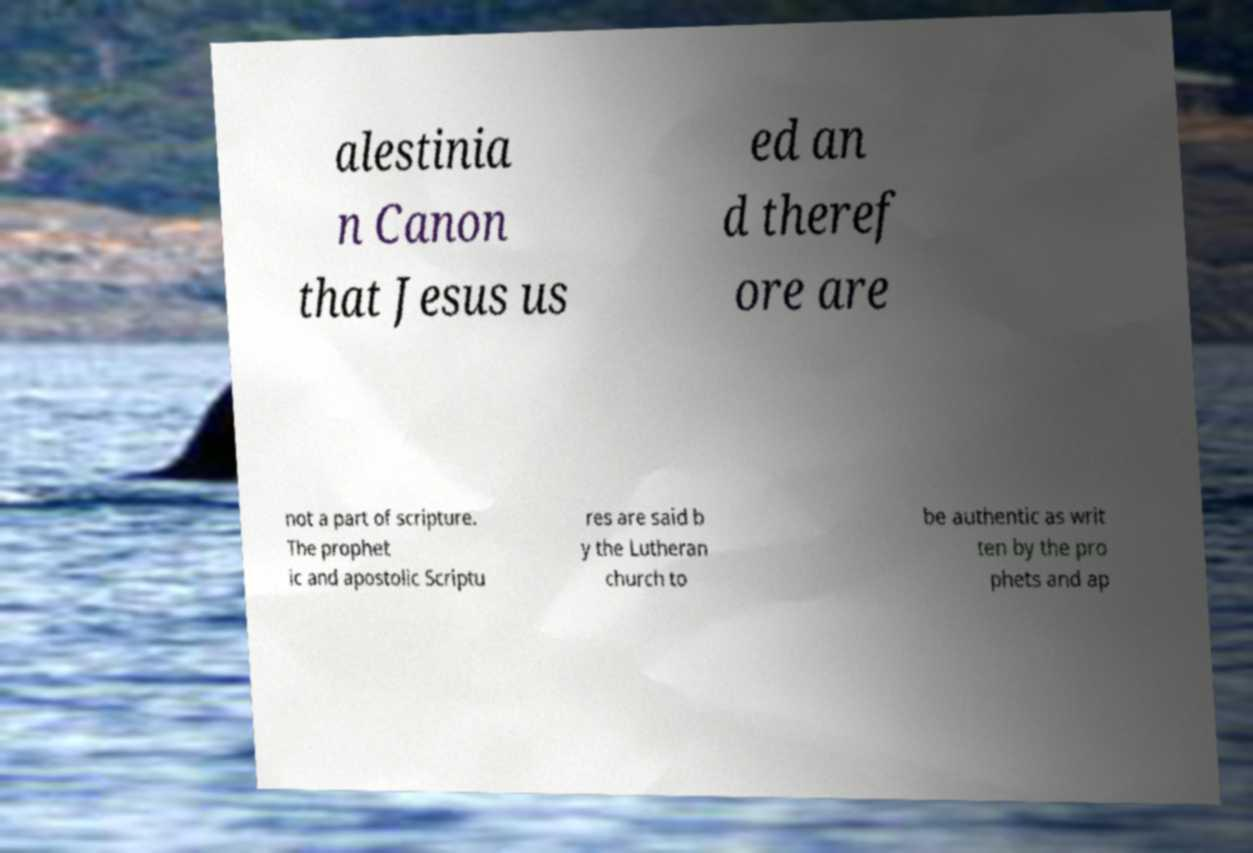I need the written content from this picture converted into text. Can you do that? alestinia n Canon that Jesus us ed an d theref ore are not a part of scripture. The prophet ic and apostolic Scriptu res are said b y the Lutheran church to be authentic as writ ten by the pro phets and ap 